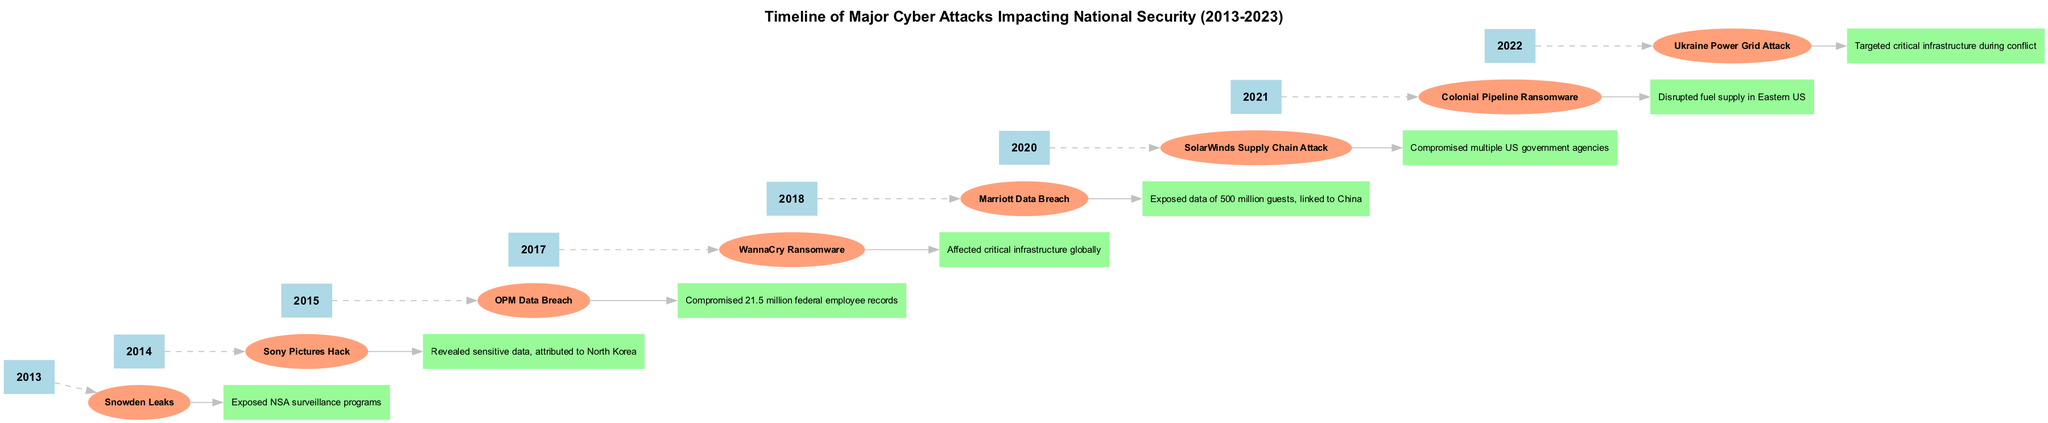What year did the Snowden Leaks occur? The diagram lists the events chronologically, and the Snowden Leaks are indicated under the year 2013.
Answer: 2013 What attack occurred in 2014? In the timeline, the event listed for 2014 is the Sony Pictures Hack.
Answer: Sony Pictures Hack How many major cyber attacks are shown in the timeline? By counting the number of events listed in the diagram, there are a total of eight major cyber attacks.
Answer: 8 Which attack compromised the most records? Among the attacks, the OPM Data Breach is noted for compromising 21.5 million federal employee records, indicating it had the largest impact in terms of data compromised.
Answer: OPM Data Breach What was the impact of the WannaCry Ransomware? The diagram states that the WannaCry Ransomware affected critical infrastructure globally, which highlights its significant impact.
Answer: Affected critical infrastructure globally Which attack is linked to North Korea? The diagram specifies that the Sony Pictures Hack, attributed to North Korea, is the only listed attack linked to that country.
Answer: Sony Pictures Hack In which year was the Colonial Pipeline Ransomware attack? The diagram indicates that the Colonial Pipeline Ransomware attack occurred in the year 2021.
Answer: 2021 How many attacks are attributed to state actors? Analyzing the events listed, both the Marriott Data Breach and the Sony Pictures Hack are attributed to state actors (China and North Korea respectively), making it two attacks.
Answer: 2 What type of diagram is this? The diagram can be classified as a timeline, as it presents events in chronological order with their corresponding impacts.
Answer: Timeline 